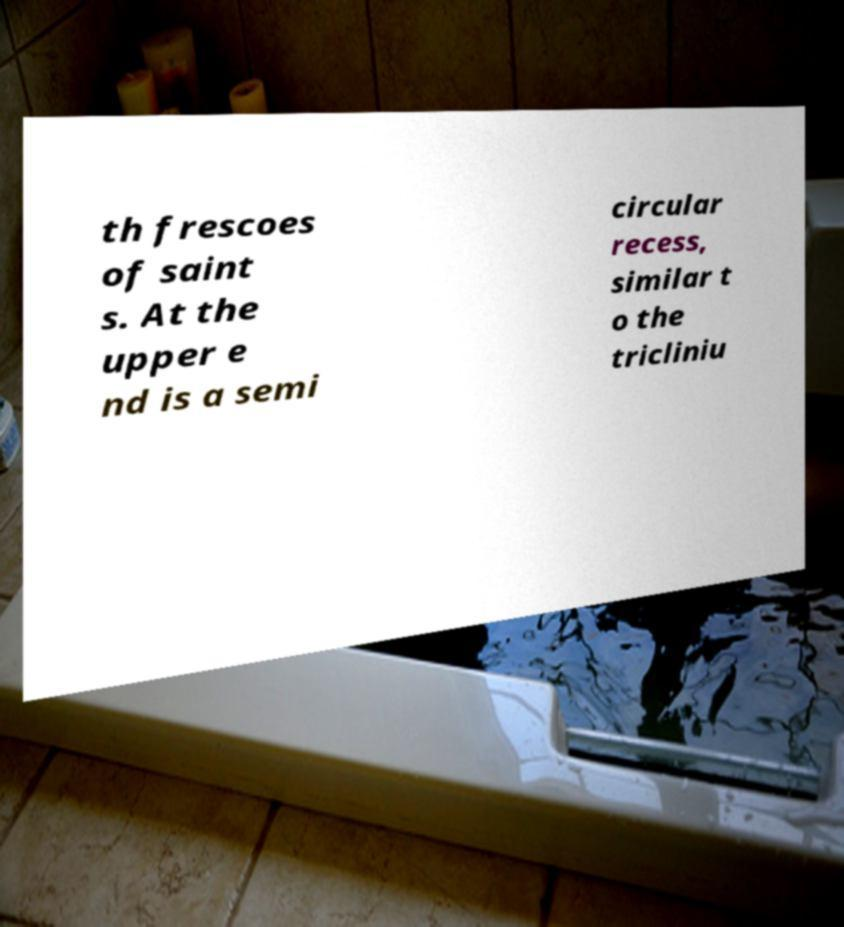Could you assist in decoding the text presented in this image and type it out clearly? th frescoes of saint s. At the upper e nd is a semi circular recess, similar t o the tricliniu 